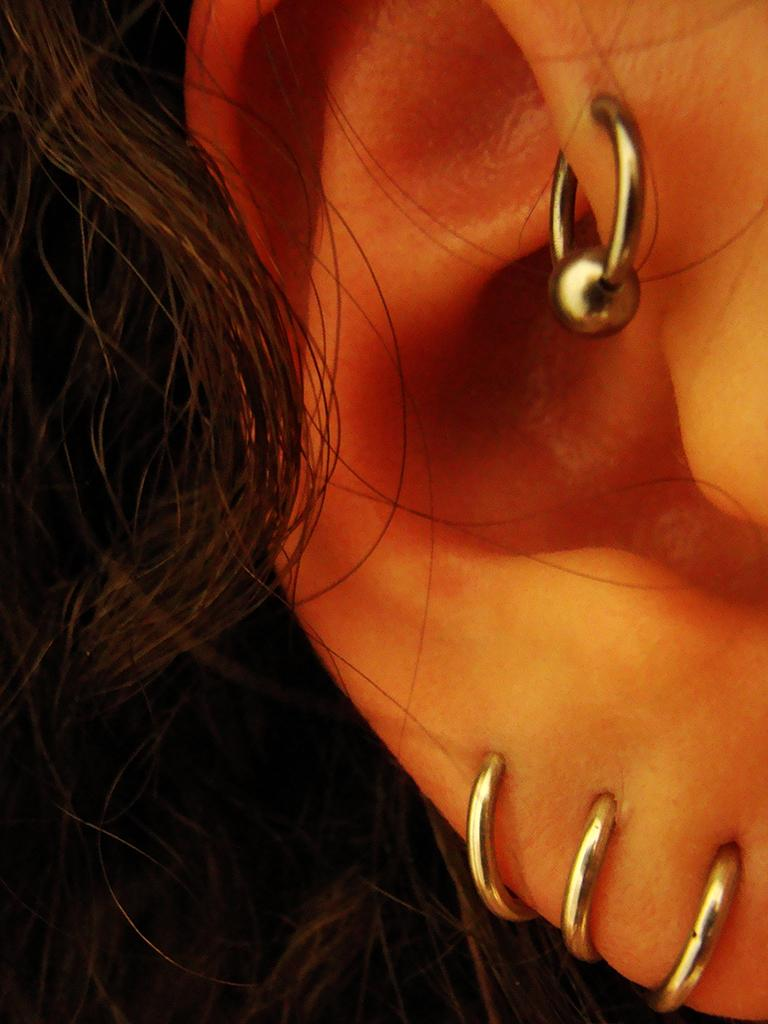What body part is the main subject of the image? There is a person's ear in the image. What is adorning the person's ear? The person's ear has earrings. What else can be seen in the image besides the ear? Hair is visible in the image. How many clovers can be seen growing in the person's ear in the image? There are no clovers present in the image; it features a person's ear with earrings. What type of system is being used to enhance the person's ear in the image? There is no system present in the image; it simply shows a person's ear with earrings. 